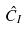<formula> <loc_0><loc_0><loc_500><loc_500>\hat { C } _ { I }</formula> 